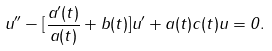<formula> <loc_0><loc_0><loc_500><loc_500>u ^ { \prime \prime } - [ \frac { a ^ { \prime } ( t ) } { a ( t ) } + b ( t ) ] u ^ { \prime } + a ( t ) c ( t ) u = 0 .</formula> 